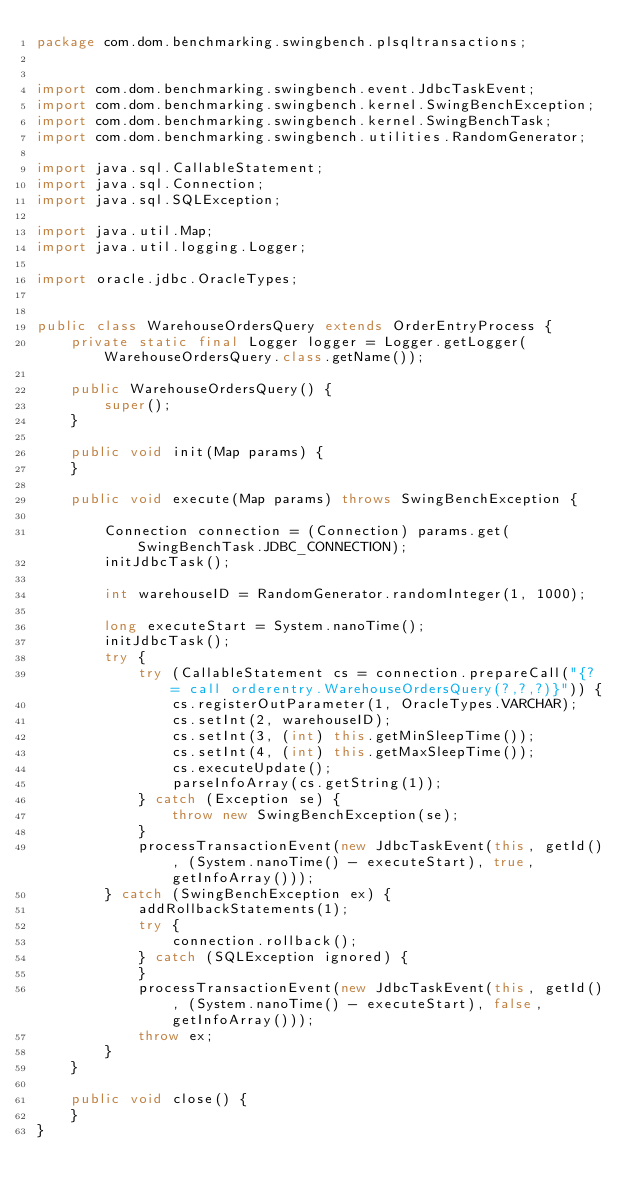<code> <loc_0><loc_0><loc_500><loc_500><_Java_>package com.dom.benchmarking.swingbench.plsqltransactions;


import com.dom.benchmarking.swingbench.event.JdbcTaskEvent;
import com.dom.benchmarking.swingbench.kernel.SwingBenchException;
import com.dom.benchmarking.swingbench.kernel.SwingBenchTask;
import com.dom.benchmarking.swingbench.utilities.RandomGenerator;

import java.sql.CallableStatement;
import java.sql.Connection;
import java.sql.SQLException;

import java.util.Map;
import java.util.logging.Logger;

import oracle.jdbc.OracleTypes;


public class WarehouseOrdersQuery extends OrderEntryProcess {
    private static final Logger logger = Logger.getLogger(WarehouseOrdersQuery.class.getName());

    public WarehouseOrdersQuery() {
        super();
    }

    public void init(Map params) {
    }

    public void execute(Map params) throws SwingBenchException {

        Connection connection = (Connection) params.get(SwingBenchTask.JDBC_CONNECTION);
        initJdbcTask();

        int warehouseID = RandomGenerator.randomInteger(1, 1000);

        long executeStart = System.nanoTime();
        initJdbcTask();
        try {
            try (CallableStatement cs = connection.prepareCall("{? = call orderentry.WarehouseOrdersQuery(?,?,?)}")) {
                cs.registerOutParameter(1, OracleTypes.VARCHAR);
                cs.setInt(2, warehouseID);
                cs.setInt(3, (int) this.getMinSleepTime());
                cs.setInt(4, (int) this.getMaxSleepTime());
                cs.executeUpdate();
                parseInfoArray(cs.getString(1));
            } catch (Exception se) {
                throw new SwingBenchException(se);
            }
            processTransactionEvent(new JdbcTaskEvent(this, getId(), (System.nanoTime() - executeStart), true, getInfoArray()));
        } catch (SwingBenchException ex) {
            addRollbackStatements(1);
            try {
                connection.rollback();
            } catch (SQLException ignored) {
            }
            processTransactionEvent(new JdbcTaskEvent(this, getId(), (System.nanoTime() - executeStart), false, getInfoArray()));
            throw ex;
        }
    }

    public void close() {
    }
}
</code> 